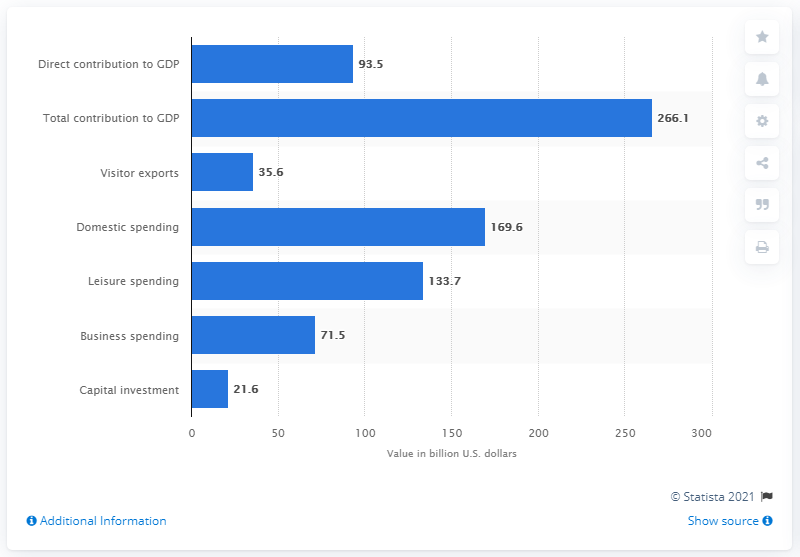Specify some key components in this picture. In 2017, the direct contribution of the travel and tourism industry to the Gross Domestic Product (GDP) of the United States was 93.5%. 